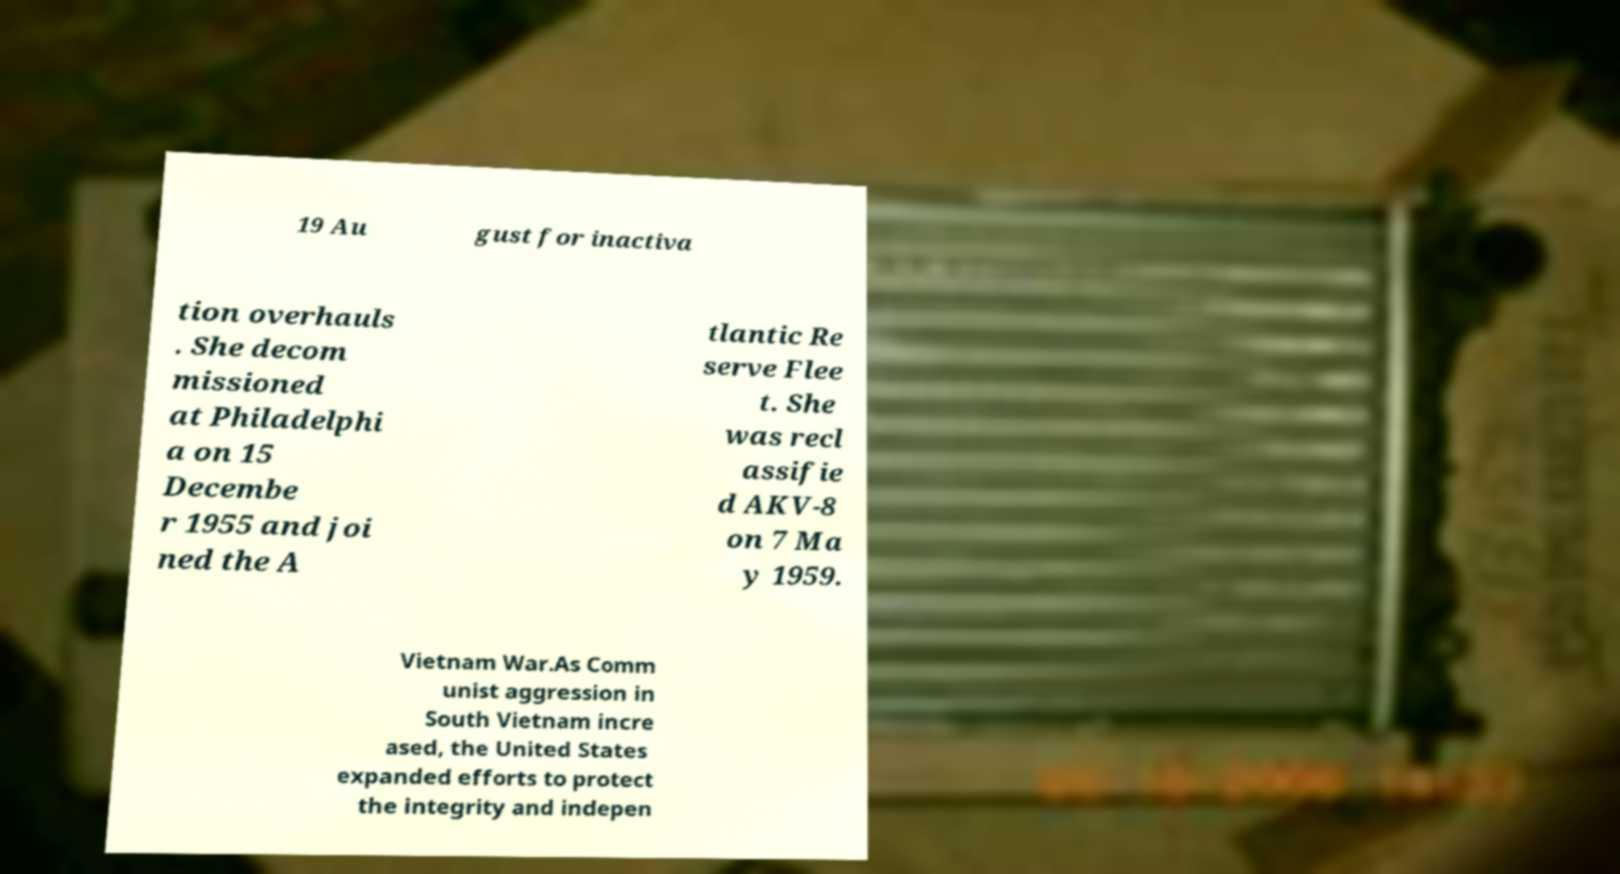Could you assist in decoding the text presented in this image and type it out clearly? 19 Au gust for inactiva tion overhauls . She decom missioned at Philadelphi a on 15 Decembe r 1955 and joi ned the A tlantic Re serve Flee t. She was recl assifie d AKV-8 on 7 Ma y 1959. Vietnam War.As Comm unist aggression in South Vietnam incre ased, the United States expanded efforts to protect the integrity and indepen 